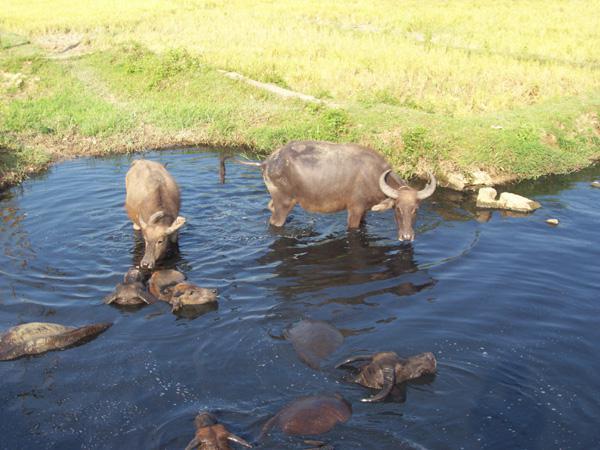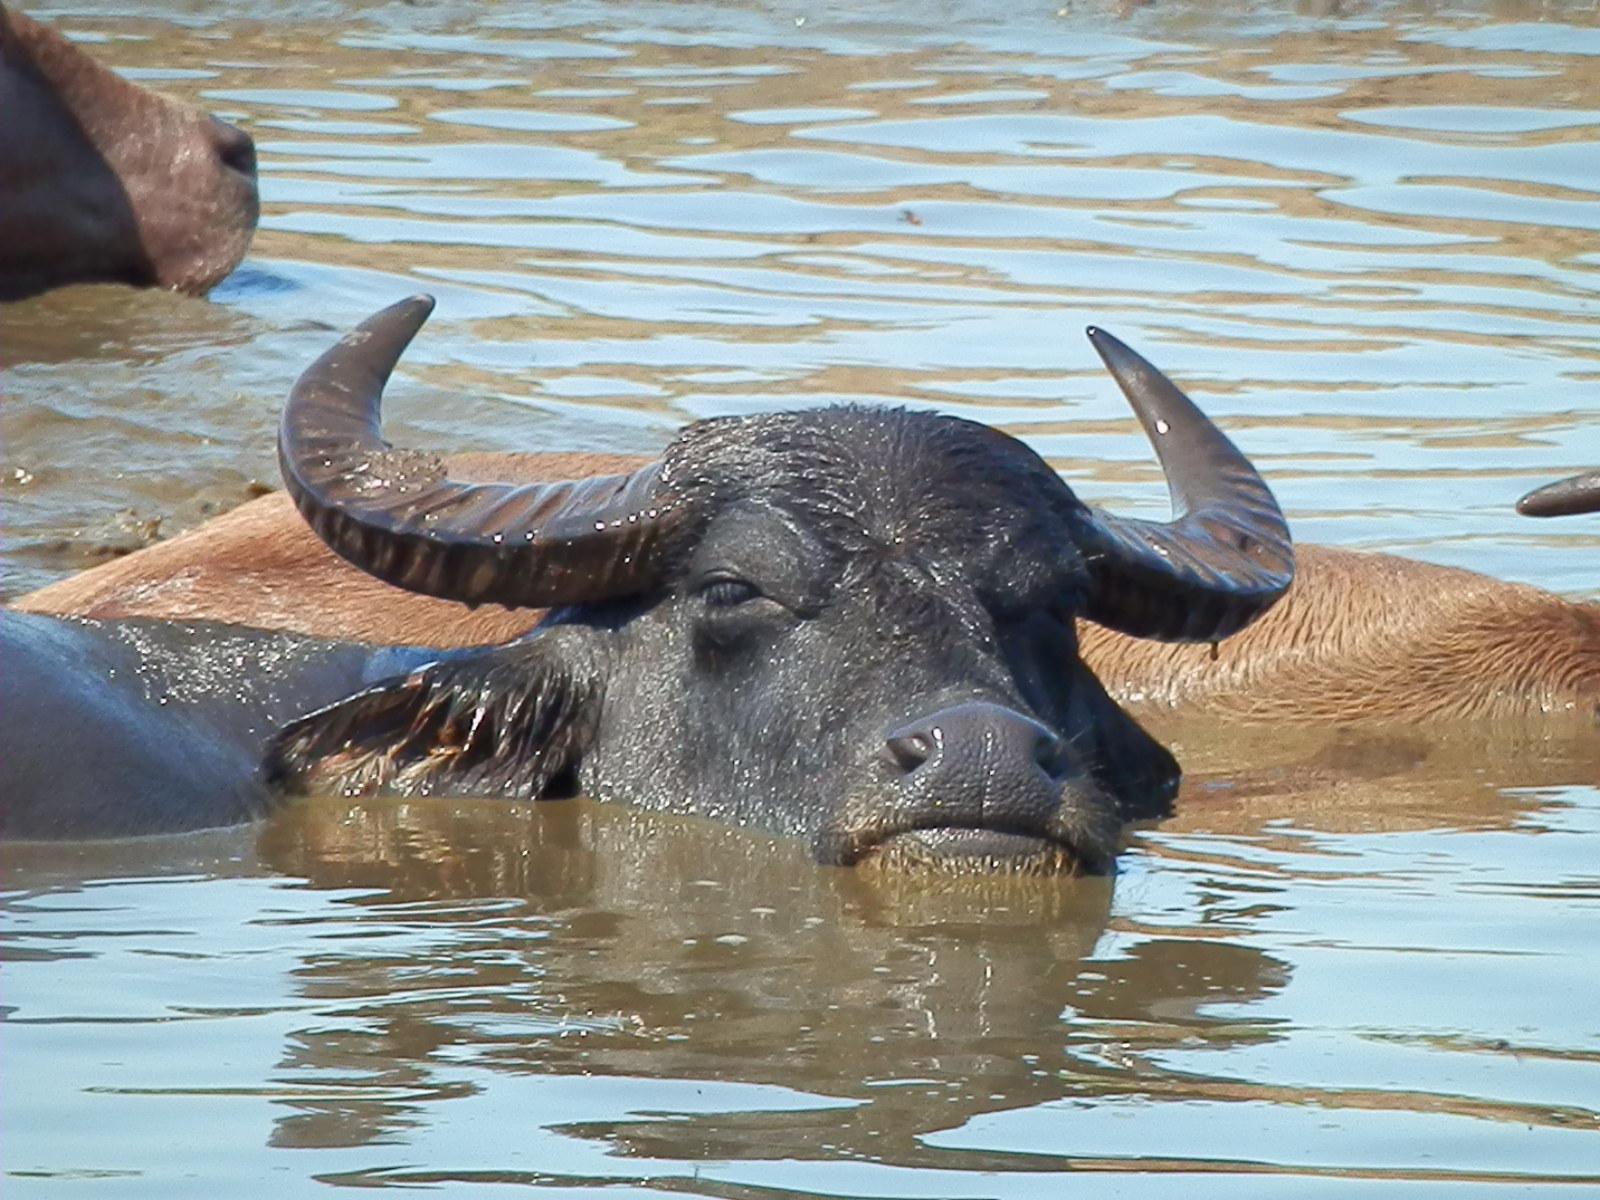The first image is the image on the left, the second image is the image on the right. Assess this claim about the two images: "At least 1 cattle is submerged to the shoulder.". Correct or not? Answer yes or no. Yes. 